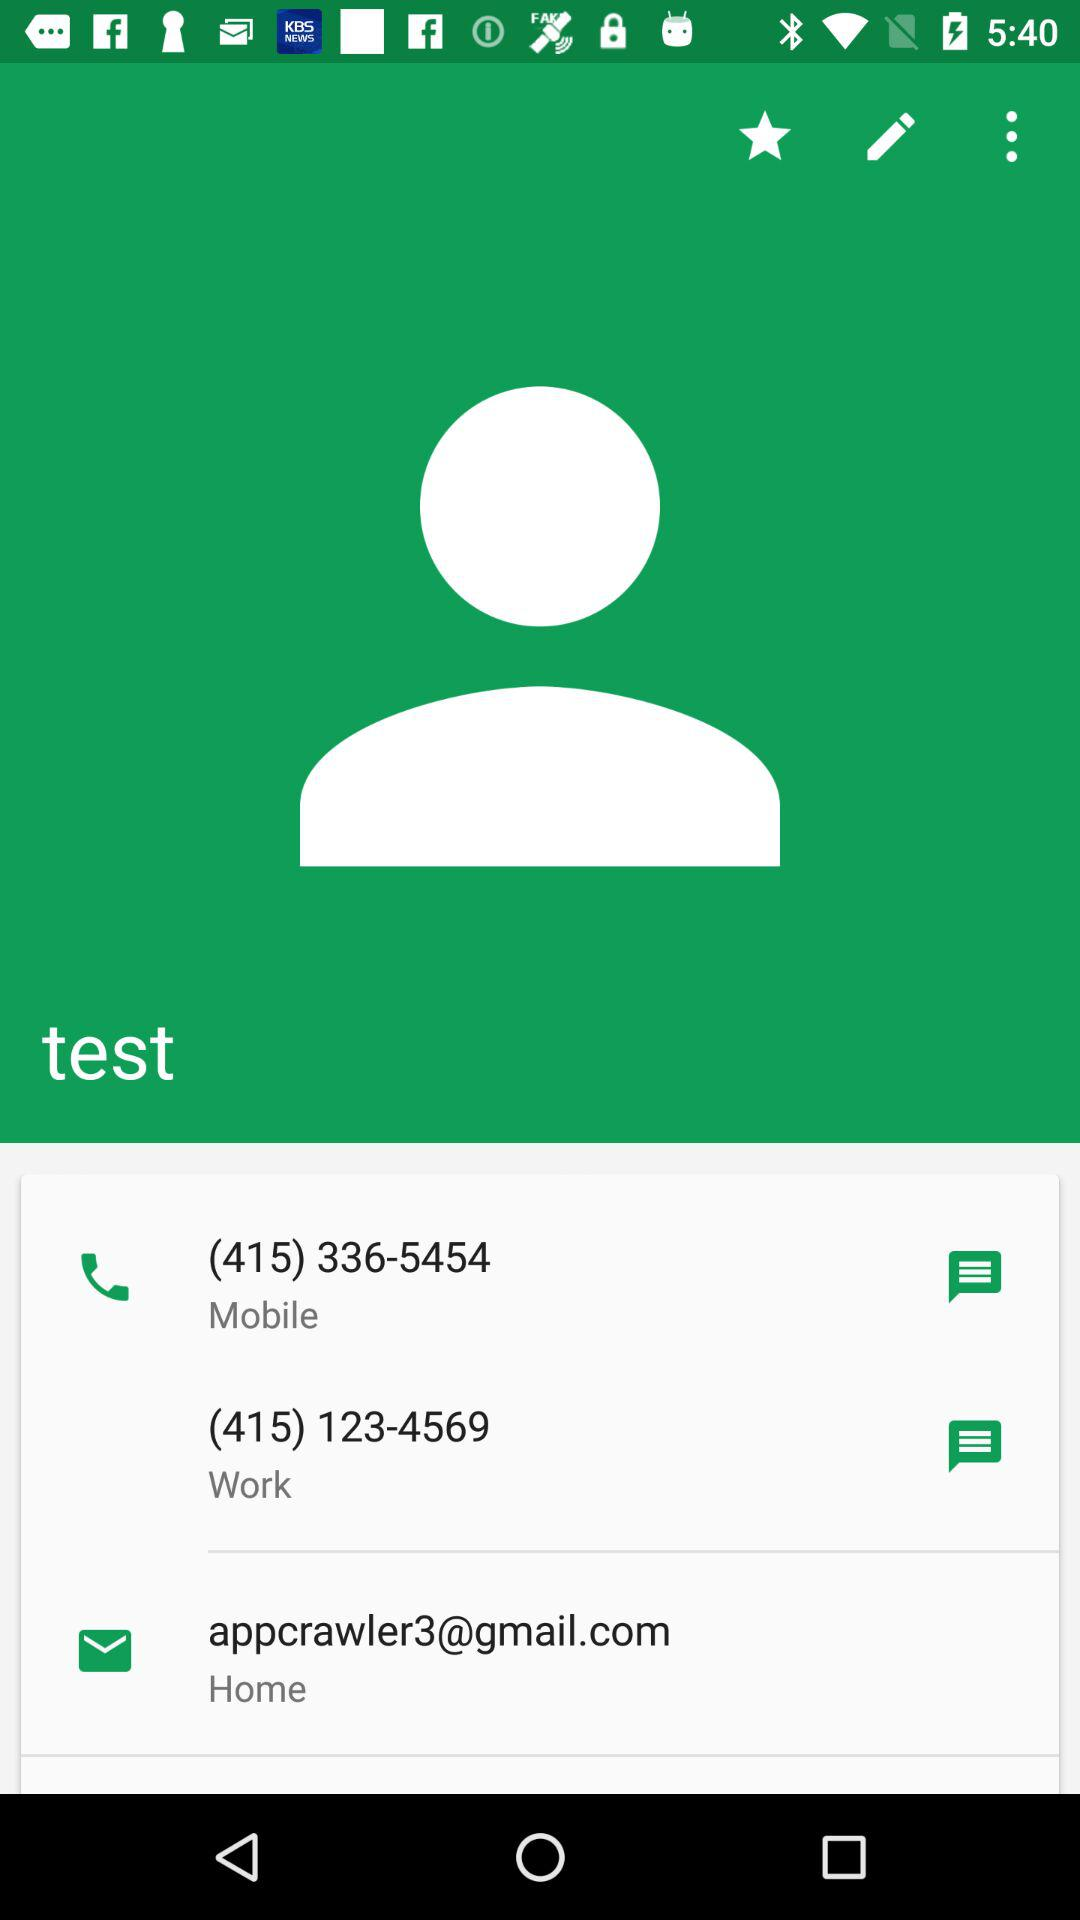What is the mobile number? The mobile number is (415) 336-5454. 